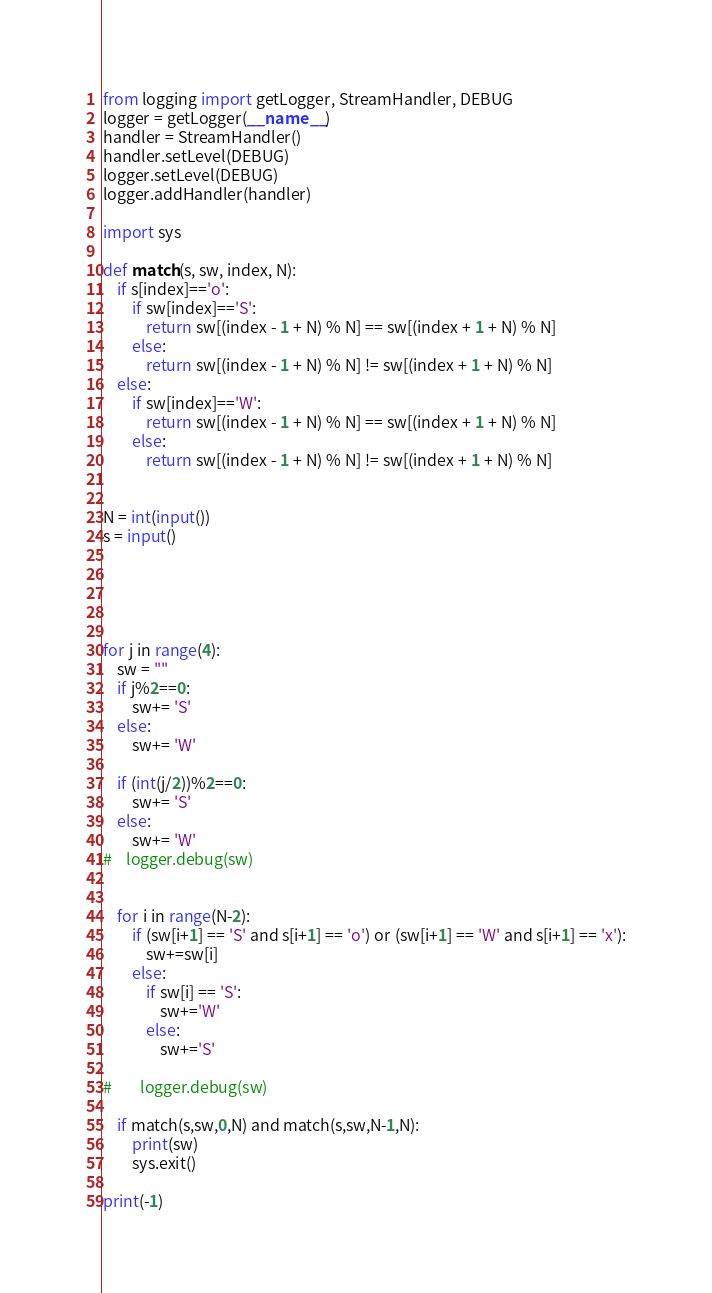<code> <loc_0><loc_0><loc_500><loc_500><_Python_>from logging import getLogger, StreamHandler, DEBUG
logger = getLogger(__name__)
handler = StreamHandler()
handler.setLevel(DEBUG)
logger.setLevel(DEBUG)
logger.addHandler(handler)

import sys

def match(s, sw, index, N):
    if s[index]=='o':
        if sw[index]=='S':
            return sw[(index - 1 + N) % N] == sw[(index + 1 + N) % N]
        else:
            return sw[(index - 1 + N) % N] != sw[(index + 1 + N) % N]
    else:
        if sw[index]=='W':
            return sw[(index - 1 + N) % N] == sw[(index + 1 + N) % N]
        else:
            return sw[(index - 1 + N) % N] != sw[(index + 1 + N) % N]


N = int(input())
s = input()


	 
    

for j in range(4):
    sw = ""
    if j%2==0:
        sw+= 'S'
    else:
        sw+= 'W'

    if (int(j/2))%2==0:
        sw+= 'S'
    else:
        sw+= 'W'
#    logger.debug(sw)


    for i in range(N-2):
        if (sw[i+1] == 'S' and s[i+1] == 'o') or (sw[i+1] == 'W' and s[i+1] == 'x'):
            sw+=sw[i]
        else:
            if sw[i] == 'S':
                sw+='W'
            else:
                sw+='S'

#        logger.debug(sw)

    if match(s,sw,0,N) and match(s,sw,N-1,N):
        print(sw)
        sys.exit()

print(-1)
</code> 